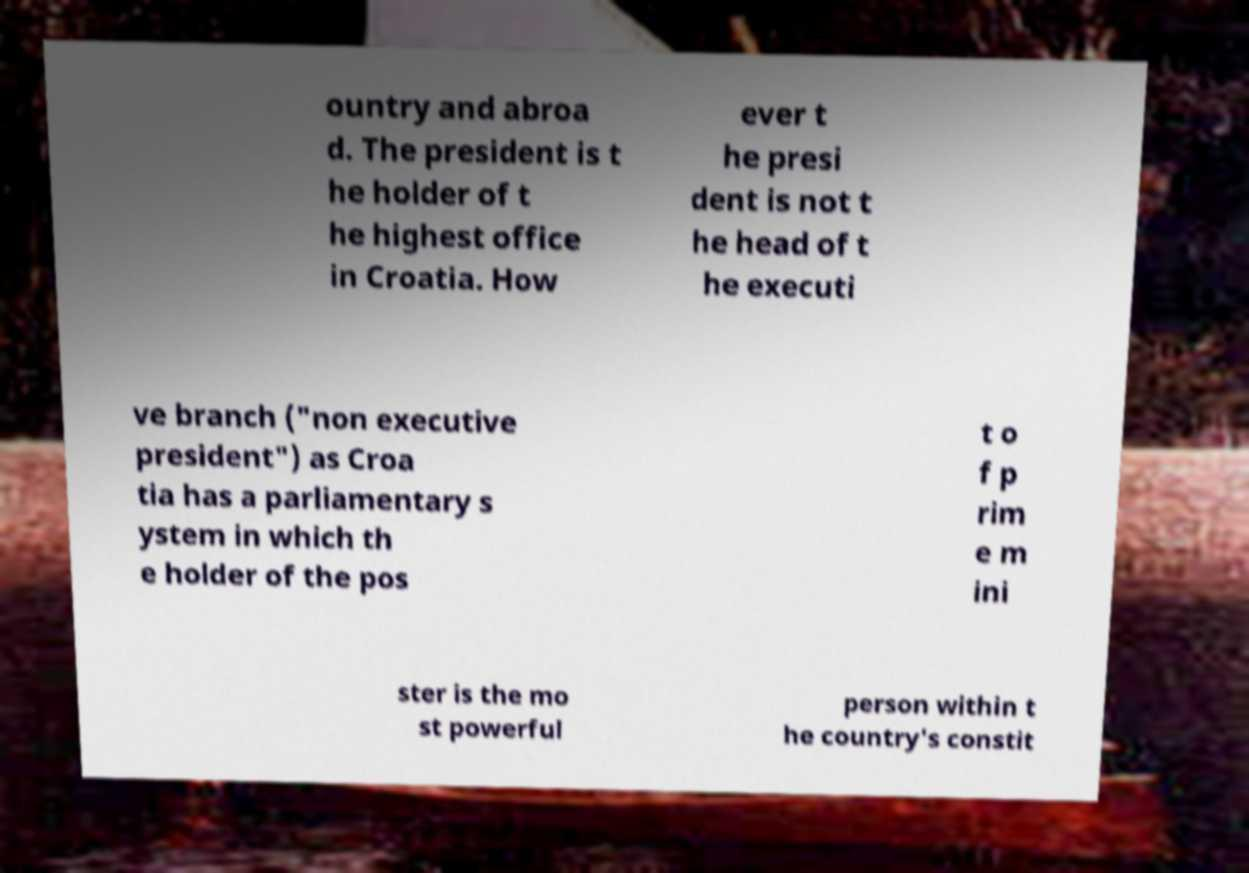For documentation purposes, I need the text within this image transcribed. Could you provide that? ountry and abroa d. The president is t he holder of t he highest office in Croatia. How ever t he presi dent is not t he head of t he executi ve branch ("non executive president") as Croa tia has a parliamentary s ystem in which th e holder of the pos t o f p rim e m ini ster is the mo st powerful person within t he country's constit 